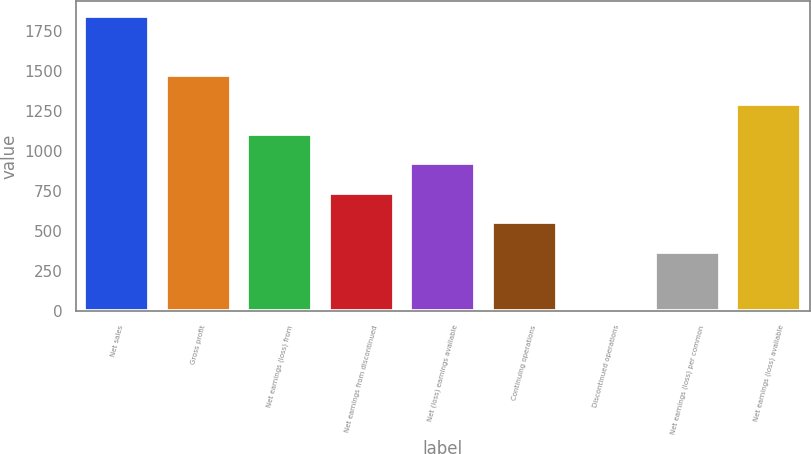<chart> <loc_0><loc_0><loc_500><loc_500><bar_chart><fcel>Net sales<fcel>Gross profit<fcel>Net earnings (loss) from<fcel>Net earnings from discontinued<fcel>Net (loss) earnings available<fcel>Continuing operations<fcel>Discontinued operations<fcel>Net earnings (loss) per common<fcel>Net earnings (loss) available<nl><fcel>1845.4<fcel>1476.33<fcel>1107.25<fcel>738.17<fcel>922.71<fcel>553.63<fcel>0.01<fcel>369.09<fcel>1291.79<nl></chart> 